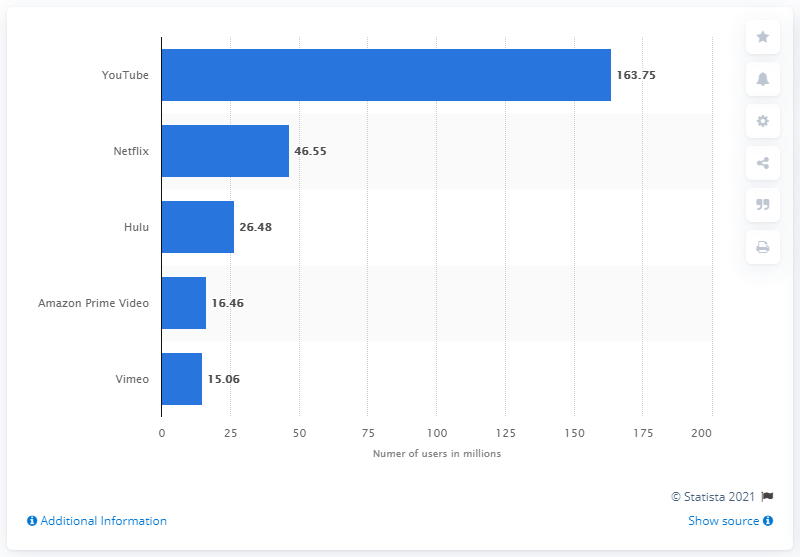Give some essential details in this illustration. As of September 2019, Hulu was the second most popular video streaming service. As of our latest data, YouTube had approximately 163.75 million monthly active users. As of March 2023, Netflix has approximately 46.55 million monthly active users. 